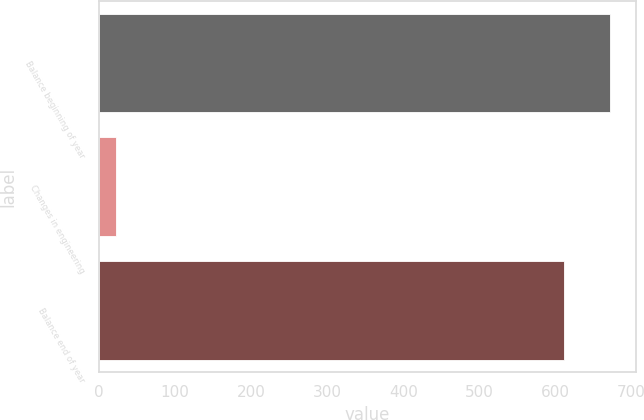<chart> <loc_0><loc_0><loc_500><loc_500><bar_chart><fcel>Balance beginning of year<fcel>Changes in engineering<fcel>Balance end of year<nl><fcel>671.9<fcel>22<fcel>612<nl></chart> 